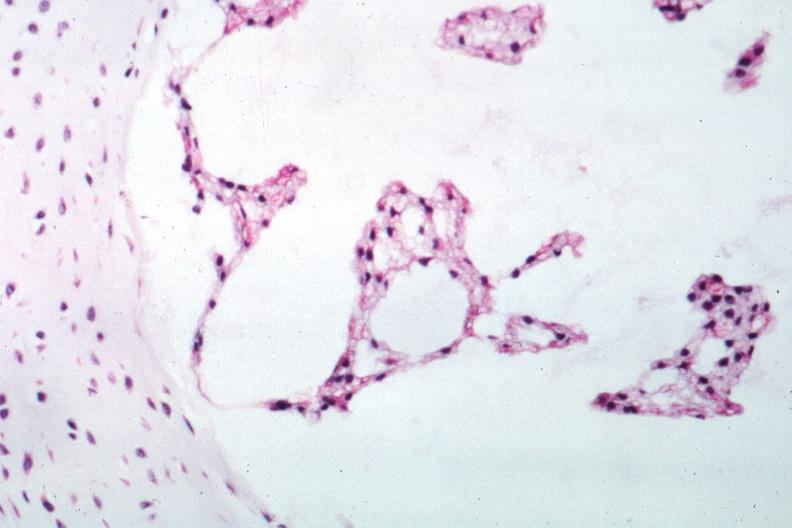what is present?
Answer the question using a single word or phrase. Notochord 